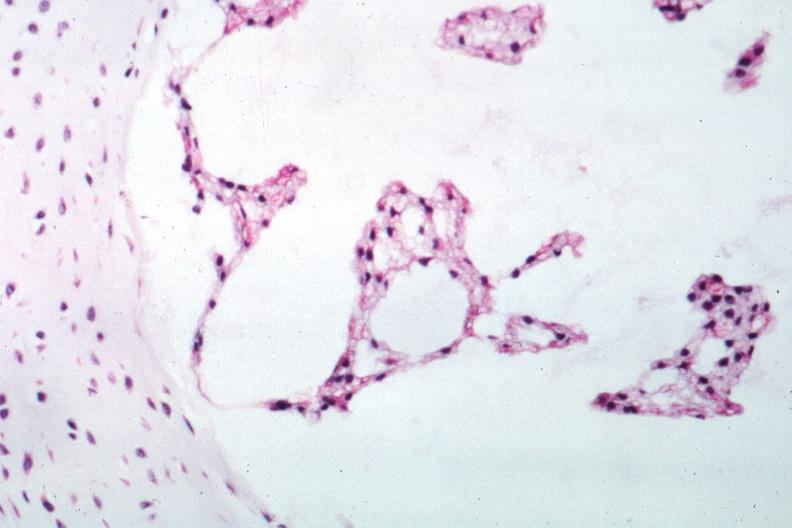what is present?
Answer the question using a single word or phrase. Notochord 